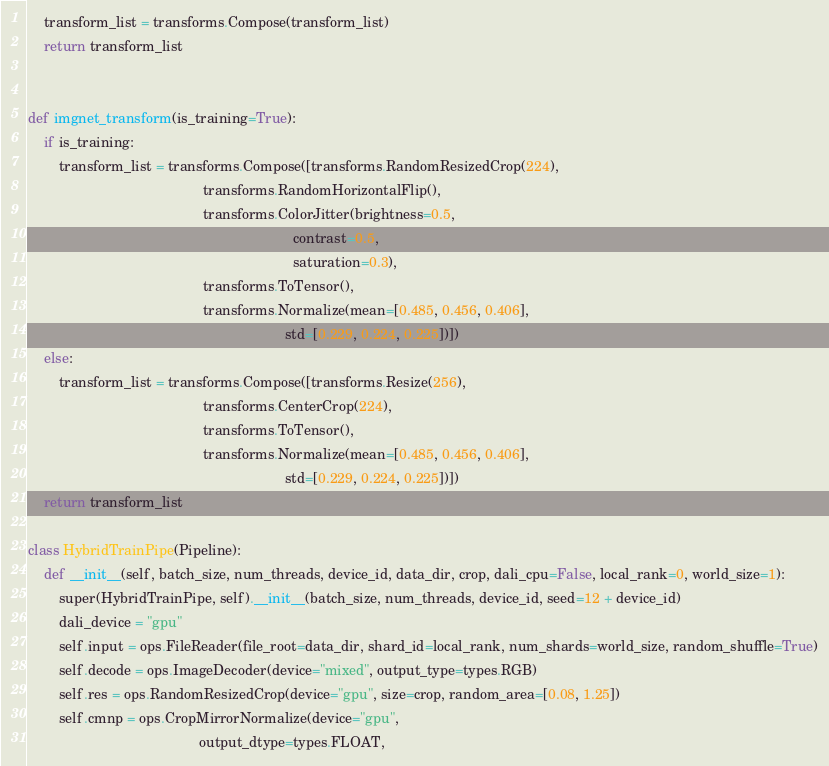<code> <loc_0><loc_0><loc_500><loc_500><_Python_>    transform_list = transforms.Compose(transform_list)
    return transform_list


def imgnet_transform(is_training=True):
    if is_training:
        transform_list = transforms.Compose([transforms.RandomResizedCrop(224),
                                             transforms.RandomHorizontalFlip(),
                                             transforms.ColorJitter(brightness=0.5,
                                                                    contrast=0.5,
                                                                    saturation=0.3),
                                             transforms.ToTensor(),
                                             transforms.Normalize(mean=[0.485, 0.456, 0.406],
                                                                  std=[0.229, 0.224, 0.225])])
    else:
        transform_list = transforms.Compose([transforms.Resize(256),
                                             transforms.CenterCrop(224),
                                             transforms.ToTensor(),
                                             transforms.Normalize(mean=[0.485, 0.456, 0.406],
                                                                  std=[0.229, 0.224, 0.225])])
    return transform_list

class HybridTrainPipe(Pipeline):
    def __init__(self, batch_size, num_threads, device_id, data_dir, crop, dali_cpu=False, local_rank=0, world_size=1):
        super(HybridTrainPipe, self).__init__(batch_size, num_threads, device_id, seed=12 + device_id)
        dali_device = "gpu"
        self.input = ops.FileReader(file_root=data_dir, shard_id=local_rank, num_shards=world_size, random_shuffle=True)
        self.decode = ops.ImageDecoder(device="mixed", output_type=types.RGB)
        self.res = ops.RandomResizedCrop(device="gpu", size=crop, random_area=[0.08, 1.25])
        self.cmnp = ops.CropMirrorNormalize(device="gpu",
                                            output_dtype=types.FLOAT,</code> 